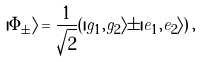Convert formula to latex. <formula><loc_0><loc_0><loc_500><loc_500>| \Phi _ { \pm } \rangle = \frac { 1 } { \sqrt { 2 } } ( | g _ { 1 } , g _ { 2 } \rangle \pm | e _ { 1 } , e _ { 2 } \rangle ) \, ,</formula> 